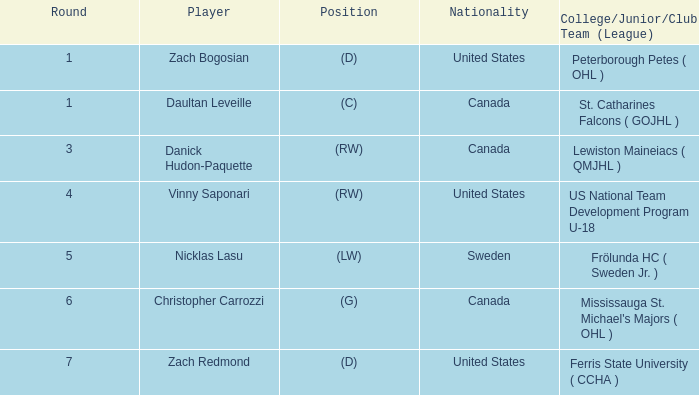I'm looking to parse the entire table for insights. Could you assist me with that? {'header': ['Round', 'Player', 'Position', 'Nationality', 'College/Junior/Club Team (League)'], 'rows': [['1', 'Zach Bogosian', '(D)', 'United States', 'Peterborough Petes ( OHL )'], ['1', 'Daultan Leveille', '(C)', 'Canada', 'St. Catharines Falcons ( GOJHL )'], ['3', 'Danick Hudon-Paquette', '(RW)', 'Canada', 'Lewiston Maineiacs ( QMJHL )'], ['4', 'Vinny Saponari', '(RW)', 'United States', 'US National Team Development Program U-18'], ['5', 'Nicklas Lasu', '(LW)', 'Sweden', 'Frölunda HC ( Sweden Jr. )'], ['6', 'Christopher Carrozzi', '(G)', 'Canada', "Mississauga St. Michael's Majors ( OHL )"], ['7', 'Zach Redmond', '(D)', 'United States', 'Ferris State University ( CCHA )']]} What is Daultan Leveille's Position? (C). 